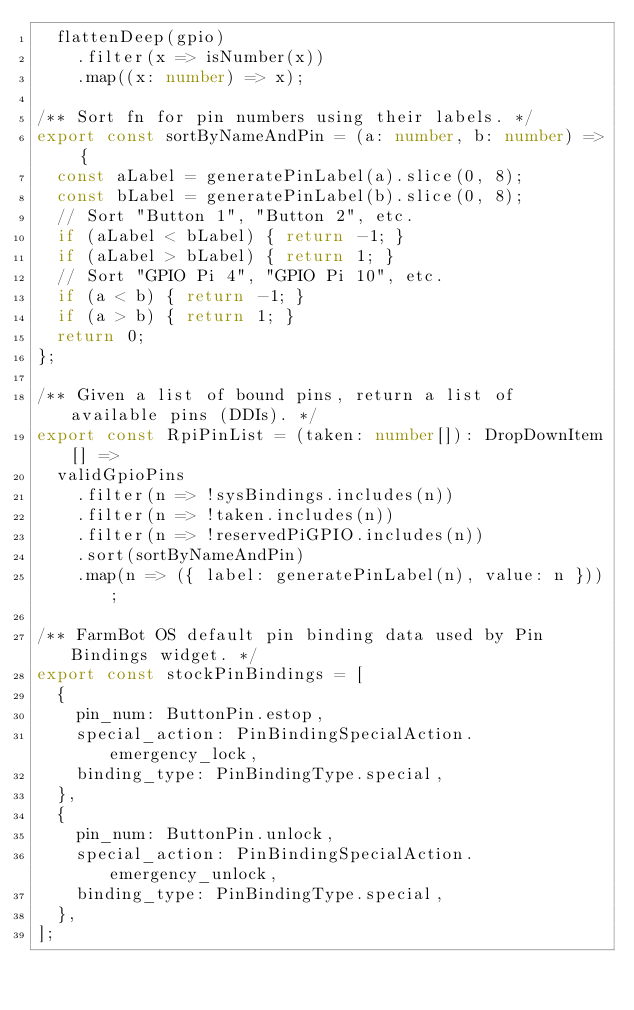Convert code to text. <code><loc_0><loc_0><loc_500><loc_500><_TypeScript_>  flattenDeep(gpio)
    .filter(x => isNumber(x))
    .map((x: number) => x);

/** Sort fn for pin numbers using their labels. */
export const sortByNameAndPin = (a: number, b: number) => {
  const aLabel = generatePinLabel(a).slice(0, 8);
  const bLabel = generatePinLabel(b).slice(0, 8);
  // Sort "Button 1", "Button 2", etc.
  if (aLabel < bLabel) { return -1; }
  if (aLabel > bLabel) { return 1; }
  // Sort "GPIO Pi 4", "GPIO Pi 10", etc.
  if (a < b) { return -1; }
  if (a > b) { return 1; }
  return 0;
};

/** Given a list of bound pins, return a list of available pins (DDIs). */
export const RpiPinList = (taken: number[]): DropDownItem[] =>
  validGpioPins
    .filter(n => !sysBindings.includes(n))
    .filter(n => !taken.includes(n))
    .filter(n => !reservedPiGPIO.includes(n))
    .sort(sortByNameAndPin)
    .map(n => ({ label: generatePinLabel(n), value: n }));

/** FarmBot OS default pin binding data used by Pin Bindings widget. */
export const stockPinBindings = [
  {
    pin_num: ButtonPin.estop,
    special_action: PinBindingSpecialAction.emergency_lock,
    binding_type: PinBindingType.special,
  },
  {
    pin_num: ButtonPin.unlock,
    special_action: PinBindingSpecialAction.emergency_unlock,
    binding_type: PinBindingType.special,
  },
];
</code> 